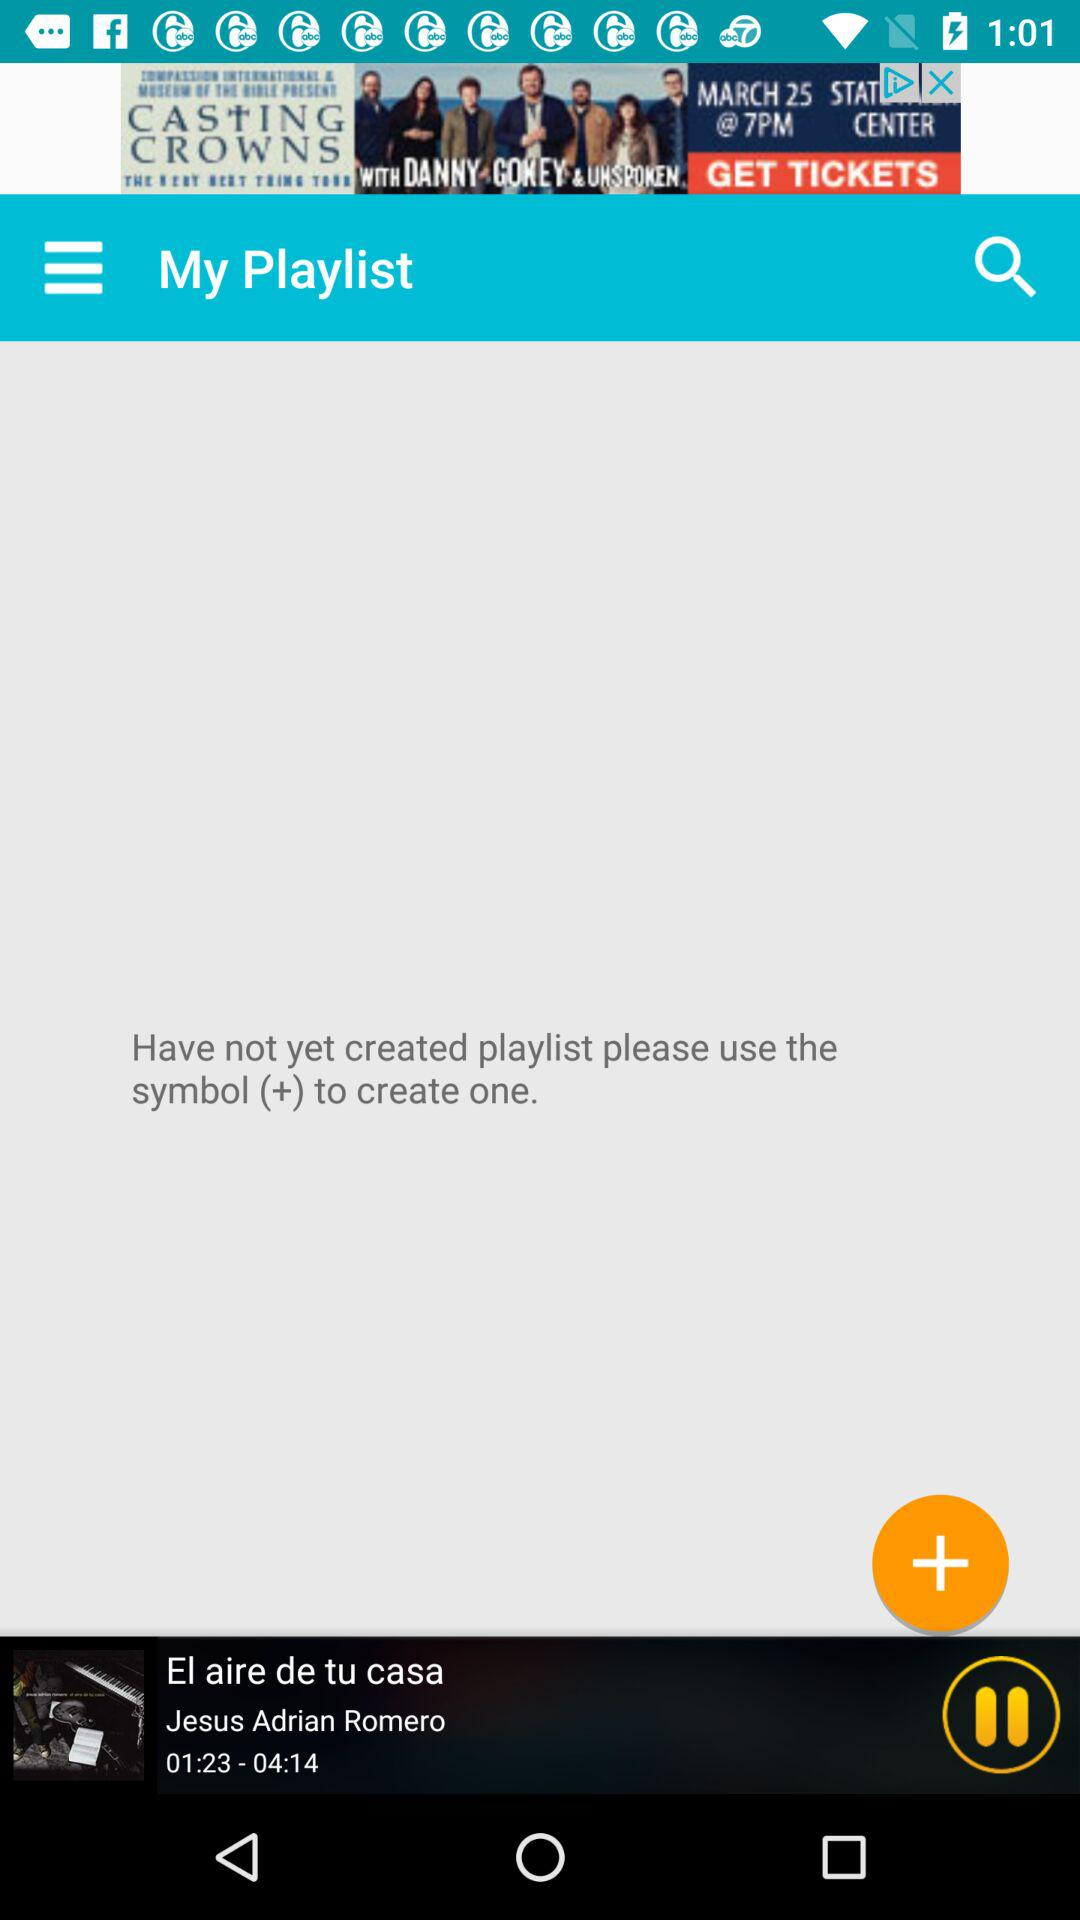What is the total length of the audio? The total length of the audio is 4 minutes 14 seconds. 